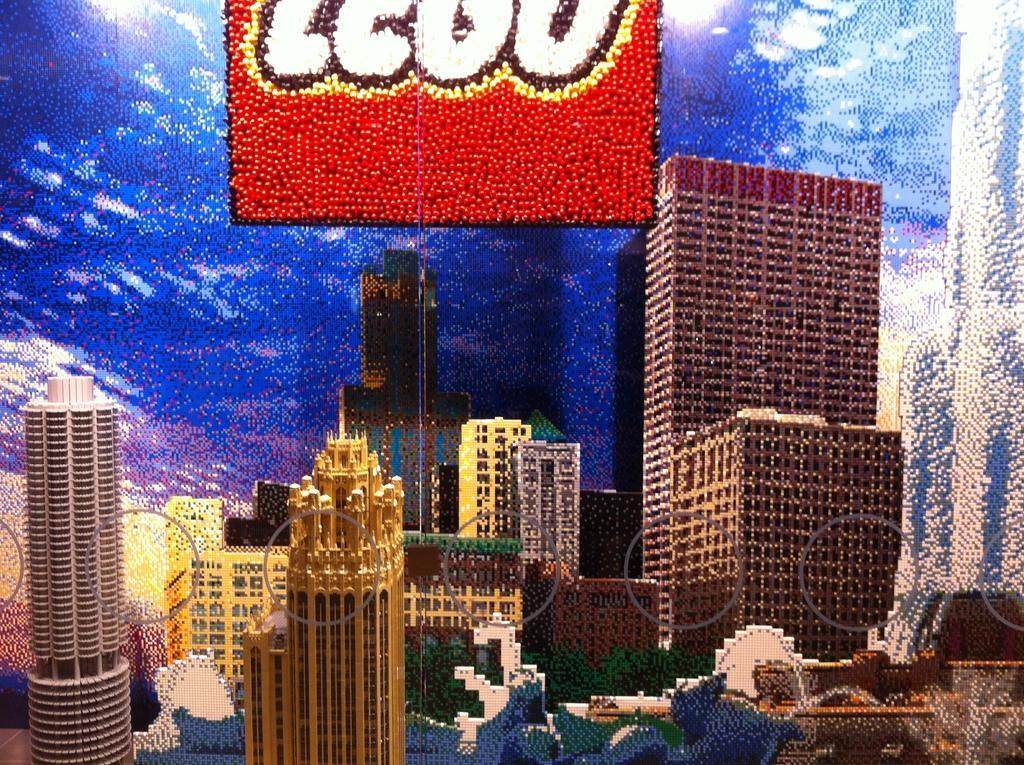How would you summarize this image in a sentence or two? This image is a graphics and here we can see buildings and trees and at the top, there is some text written. 